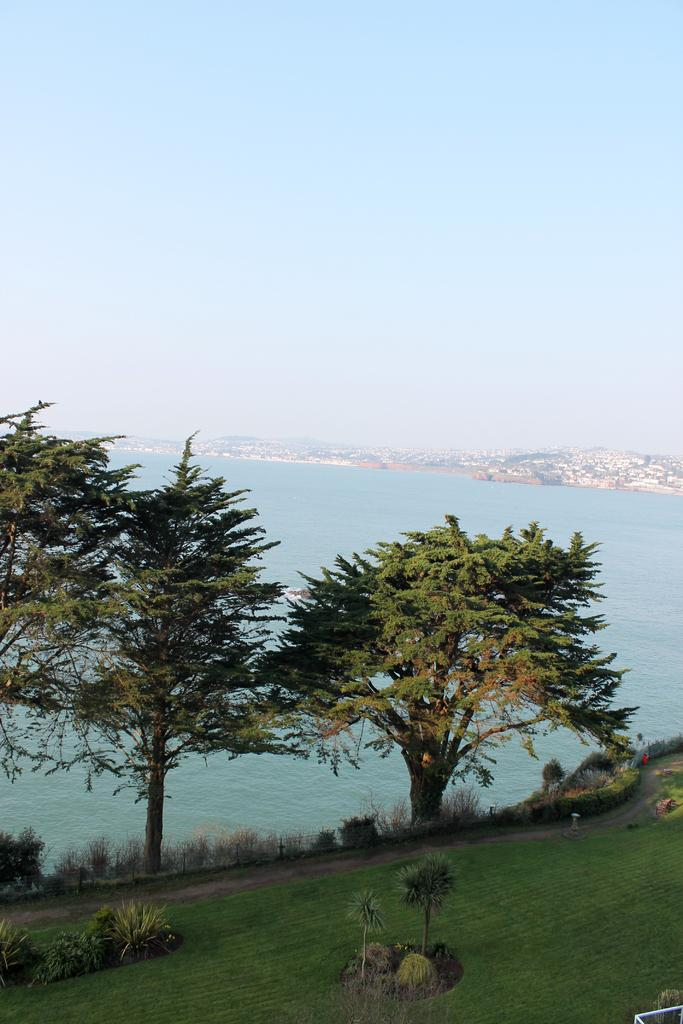What type of vegetation can be seen in the image? There are trees, plants, and grass in the image. What natural feature is visible in the image? The sea is visible in the image. What type of structures can be seen in the background of the image? There are buildings in the background of the image. What part of the natural environment is visible in the image? The sky is visible in the image. What type of toys can be seen floating in the sea in the image? There are no toys visible in the image; it only shows trees, plants, grass, the sea, buildings, and the sky. 